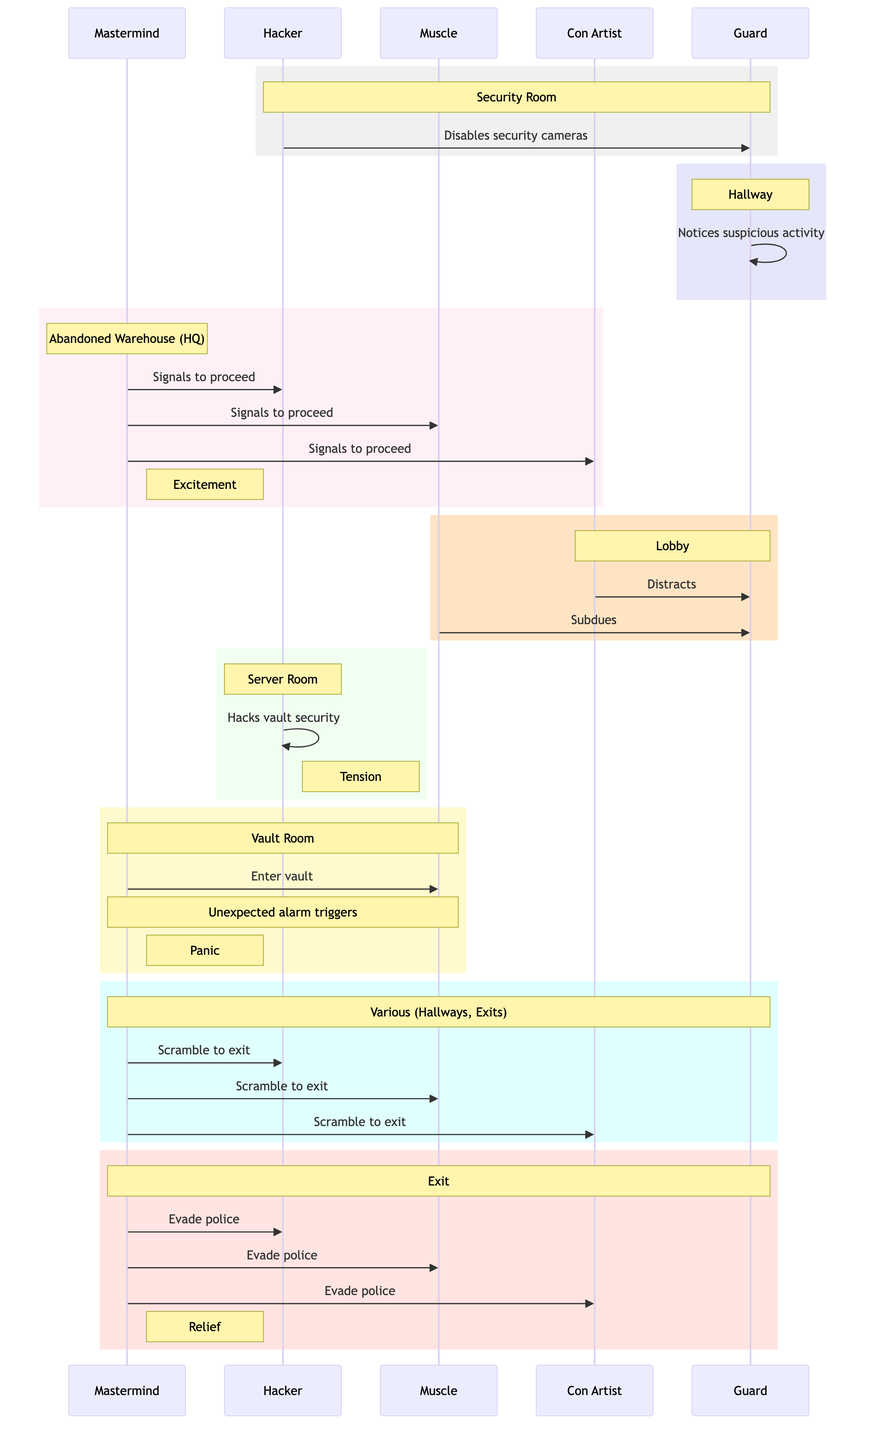What is the first action taken by the Hacker? The first action recorded in the sequence is "Hacker disables security cameras." This is indicated in the first rectangle of the diagram where the action is listed.
Answer: Hacker disables security cameras How many actors are involved in the heist? The diagram lists five actors involved in the heist: Mastermind, Hacker, Muscle, Con Artist, and Guard. This can be counted from the "actors" section in the provided data.
Answer: Five What emotion is associated with the action "Mastermind signals the team to proceed"? The emotion associated with that action is "Excitement," which is noted beside the action in the diagram.
Answer: Excitement Which location is the action "Hacker hacks into vault security" associated with? This action takes place in the "Server Room," as indicated in the rectangle that describes the action's location in the diagram.
Answer: Server Room How many consecutive set shifts occur before the unexpected alarm triggers? There are three consecutive set shifts before the unexpected alarm triggers. They are: "Lobby," "Server Room," and "Vault Room." These can be traced in the sequence of actions leading to the alarm.
Answer: Three What is the last recorded action in the diagram? The last recorded action is "Team evades arriving police," which is clearly stated in the final rectangle of the diagram.
Answer: Team evades arriving police What is the location associated with the action performed by the Muscle? The Muscle's action of subduing the Guard takes place in the "Lobby," which is denoted in the rectangle describing the actions of the Con Artist and Muscle.
Answer: Lobby Which emotional point corresponds with the action where an unexpected alarm triggers? The emotional point that corresponds with the unexpected alarm triggering is "Panic," indicated next to the related action in the diagram.
Answer: Panic How many total actions are shown in the sequence diagram? There are ten actions shown in the sequence diagram, which can be counted from the sequence array in the provided data.
Answer: Ten 